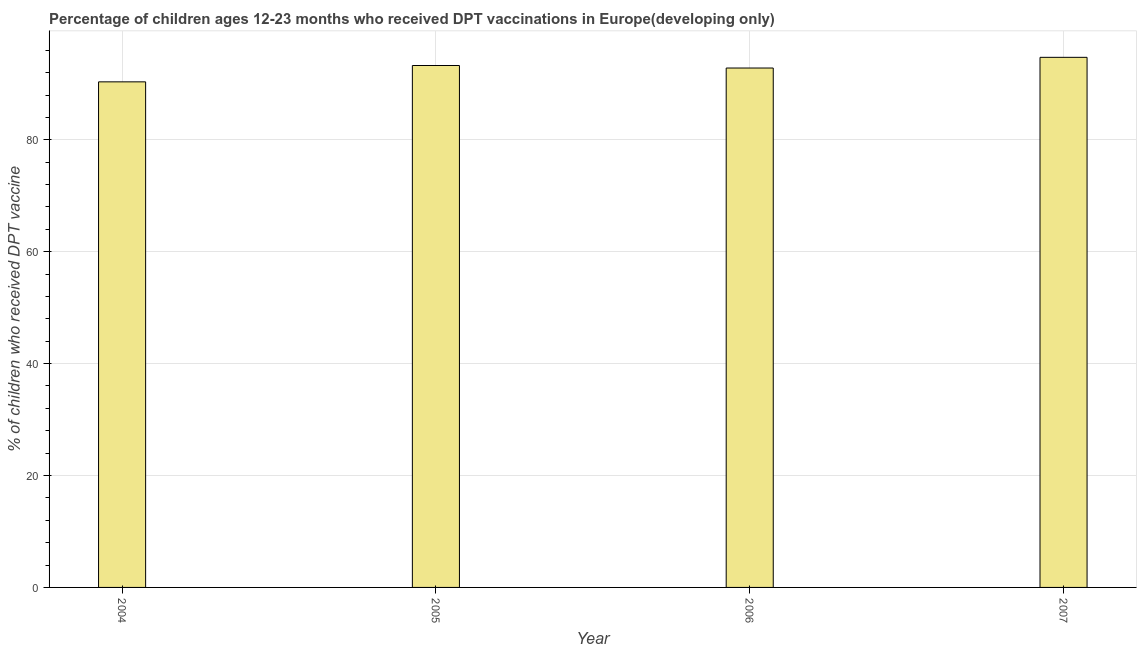What is the title of the graph?
Provide a short and direct response. Percentage of children ages 12-23 months who received DPT vaccinations in Europe(developing only). What is the label or title of the X-axis?
Your answer should be very brief. Year. What is the label or title of the Y-axis?
Your answer should be compact. % of children who received DPT vaccine. What is the percentage of children who received dpt vaccine in 2004?
Provide a short and direct response. 90.35. Across all years, what is the maximum percentage of children who received dpt vaccine?
Your answer should be very brief. 94.73. Across all years, what is the minimum percentage of children who received dpt vaccine?
Your answer should be compact. 90.35. In which year was the percentage of children who received dpt vaccine maximum?
Provide a succinct answer. 2007. In which year was the percentage of children who received dpt vaccine minimum?
Your answer should be very brief. 2004. What is the sum of the percentage of children who received dpt vaccine?
Offer a terse response. 371.19. What is the difference between the percentage of children who received dpt vaccine in 2004 and 2006?
Provide a succinct answer. -2.47. What is the average percentage of children who received dpt vaccine per year?
Give a very brief answer. 92.8. What is the median percentage of children who received dpt vaccine?
Offer a very short reply. 93.05. Do a majority of the years between 2004 and 2005 (inclusive) have percentage of children who received dpt vaccine greater than 56 %?
Give a very brief answer. Yes. What is the ratio of the percentage of children who received dpt vaccine in 2004 to that in 2007?
Offer a terse response. 0.95. Is the percentage of children who received dpt vaccine in 2004 less than that in 2005?
Provide a short and direct response. Yes. Is the difference between the percentage of children who received dpt vaccine in 2004 and 2007 greater than the difference between any two years?
Ensure brevity in your answer.  Yes. What is the difference between the highest and the second highest percentage of children who received dpt vaccine?
Your answer should be very brief. 1.46. What is the difference between the highest and the lowest percentage of children who received dpt vaccine?
Your answer should be compact. 4.38. How many years are there in the graph?
Offer a very short reply. 4. What is the % of children who received DPT vaccine in 2004?
Keep it short and to the point. 90.35. What is the % of children who received DPT vaccine in 2005?
Offer a very short reply. 93.27. What is the % of children who received DPT vaccine of 2006?
Make the answer very short. 92.82. What is the % of children who received DPT vaccine of 2007?
Provide a short and direct response. 94.73. What is the difference between the % of children who received DPT vaccine in 2004 and 2005?
Ensure brevity in your answer.  -2.92. What is the difference between the % of children who received DPT vaccine in 2004 and 2006?
Provide a short and direct response. -2.47. What is the difference between the % of children who received DPT vaccine in 2004 and 2007?
Your answer should be very brief. -4.38. What is the difference between the % of children who received DPT vaccine in 2005 and 2006?
Ensure brevity in your answer.  0.45. What is the difference between the % of children who received DPT vaccine in 2005 and 2007?
Ensure brevity in your answer.  -1.46. What is the difference between the % of children who received DPT vaccine in 2006 and 2007?
Offer a terse response. -1.91. What is the ratio of the % of children who received DPT vaccine in 2004 to that in 2005?
Provide a succinct answer. 0.97. What is the ratio of the % of children who received DPT vaccine in 2004 to that in 2007?
Ensure brevity in your answer.  0.95. What is the ratio of the % of children who received DPT vaccine in 2005 to that in 2006?
Offer a very short reply. 1. What is the ratio of the % of children who received DPT vaccine in 2006 to that in 2007?
Your response must be concise. 0.98. 